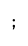<code> <loc_0><loc_0><loc_500><loc_500><_SQL_>;

</code> 